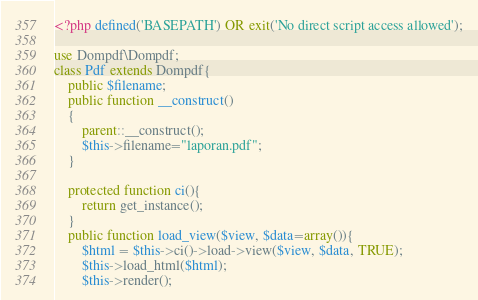<code> <loc_0><loc_0><loc_500><loc_500><_PHP_><?php defined('BASEPATH') OR exit('No direct script access allowed');

use Dompdf\Dompdf;
class Pdf extends Dompdf{
    public $filename;
    public function __construct()
    {
        parent::__construct();
        $this->filename="laporan.pdf";
    }

    protected function ci(){
        return get_instance();
    }
    public function load_view($view, $data=array()){
        $html = $this->ci()->load->view($view, $data, TRUE);
        $this->load_html($html);
        $this->render();</code> 